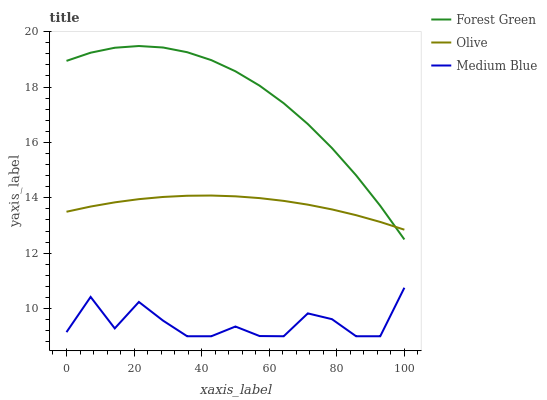Does Medium Blue have the minimum area under the curve?
Answer yes or no. Yes. Does Forest Green have the maximum area under the curve?
Answer yes or no. Yes. Does Forest Green have the minimum area under the curve?
Answer yes or no. No. Does Medium Blue have the maximum area under the curve?
Answer yes or no. No. Is Olive the smoothest?
Answer yes or no. Yes. Is Medium Blue the roughest?
Answer yes or no. Yes. Is Forest Green the smoothest?
Answer yes or no. No. Is Forest Green the roughest?
Answer yes or no. No. Does Medium Blue have the lowest value?
Answer yes or no. Yes. Does Forest Green have the lowest value?
Answer yes or no. No. Does Forest Green have the highest value?
Answer yes or no. Yes. Does Medium Blue have the highest value?
Answer yes or no. No. Is Medium Blue less than Forest Green?
Answer yes or no. Yes. Is Forest Green greater than Medium Blue?
Answer yes or no. Yes. Does Olive intersect Forest Green?
Answer yes or no. Yes. Is Olive less than Forest Green?
Answer yes or no. No. Is Olive greater than Forest Green?
Answer yes or no. No. Does Medium Blue intersect Forest Green?
Answer yes or no. No. 